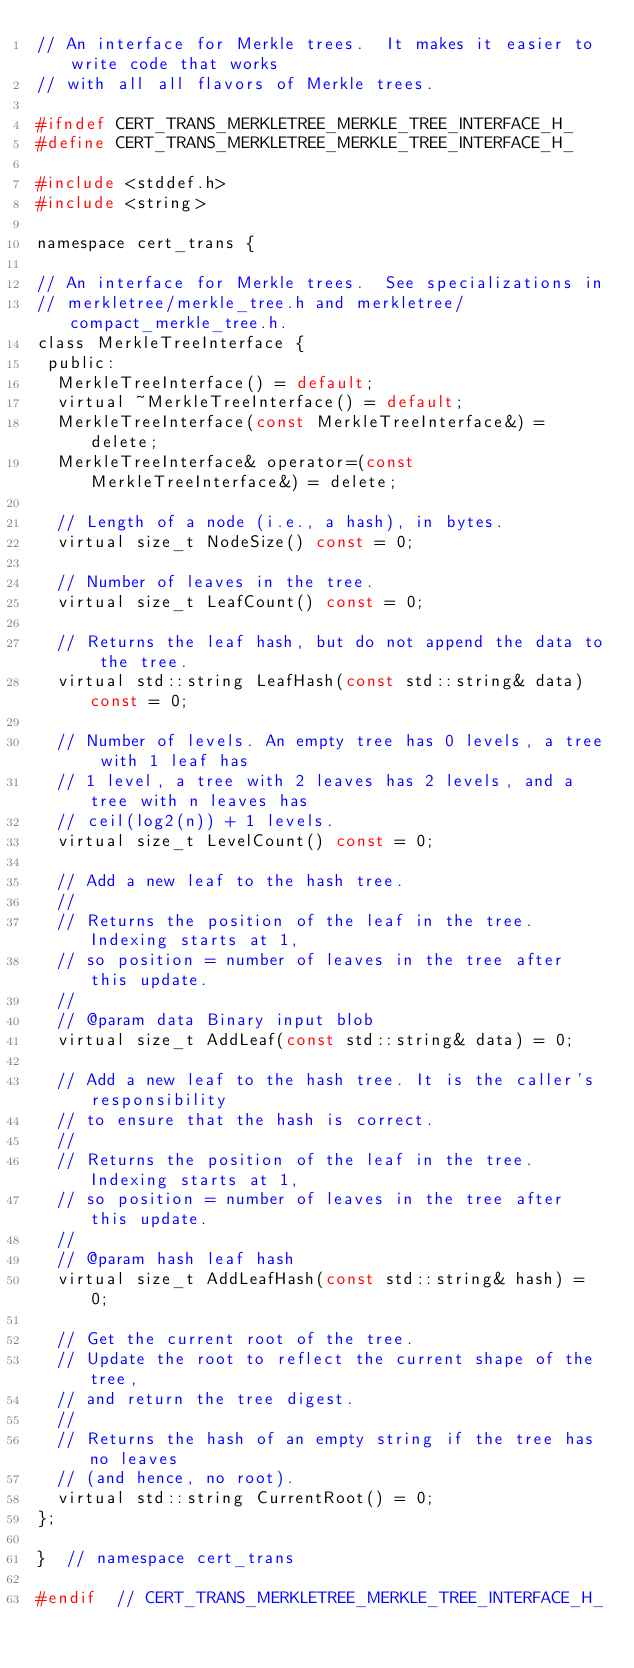<code> <loc_0><loc_0><loc_500><loc_500><_C_>// An interface for Merkle trees.  It makes it easier to write code that works
// with all all flavors of Merkle trees.

#ifndef CERT_TRANS_MERKLETREE_MERKLE_TREE_INTERFACE_H_
#define CERT_TRANS_MERKLETREE_MERKLE_TREE_INTERFACE_H_

#include <stddef.h>
#include <string>

namespace cert_trans {

// An interface for Merkle trees.  See specializations in
// merkletree/merkle_tree.h and merkletree/compact_merkle_tree.h.
class MerkleTreeInterface {
 public:
  MerkleTreeInterface() = default;
  virtual ~MerkleTreeInterface() = default;
  MerkleTreeInterface(const MerkleTreeInterface&) = delete;
  MerkleTreeInterface& operator=(const MerkleTreeInterface&) = delete;

  // Length of a node (i.e., a hash), in bytes.
  virtual size_t NodeSize() const = 0;

  // Number of leaves in the tree.
  virtual size_t LeafCount() const = 0;

  // Returns the leaf hash, but do not append the data to the tree.
  virtual std::string LeafHash(const std::string& data) const = 0;

  // Number of levels. An empty tree has 0 levels, a tree with 1 leaf has
  // 1 level, a tree with 2 leaves has 2 levels, and a tree with n leaves has
  // ceil(log2(n)) + 1 levels.
  virtual size_t LevelCount() const = 0;

  // Add a new leaf to the hash tree.
  //
  // Returns the position of the leaf in the tree. Indexing starts at 1,
  // so position = number of leaves in the tree after this update.
  //
  // @param data Binary input blob
  virtual size_t AddLeaf(const std::string& data) = 0;

  // Add a new leaf to the hash tree. It is the caller's responsibility
  // to ensure that the hash is correct.
  //
  // Returns the position of the leaf in the tree. Indexing starts at 1,
  // so position = number of leaves in the tree after this update.
  //
  // @param hash leaf hash
  virtual size_t AddLeafHash(const std::string& hash) = 0;

  // Get the current root of the tree.
  // Update the root to reflect the current shape of the tree,
  // and return the tree digest.
  //
  // Returns the hash of an empty string if the tree has no leaves
  // (and hence, no root).
  virtual std::string CurrentRoot() = 0;
};

}  // namespace cert_trans

#endif  // CERT_TRANS_MERKLETREE_MERKLE_TREE_INTERFACE_H_
</code> 